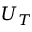Convert formula to latex. <formula><loc_0><loc_0><loc_500><loc_500>U _ { T }</formula> 